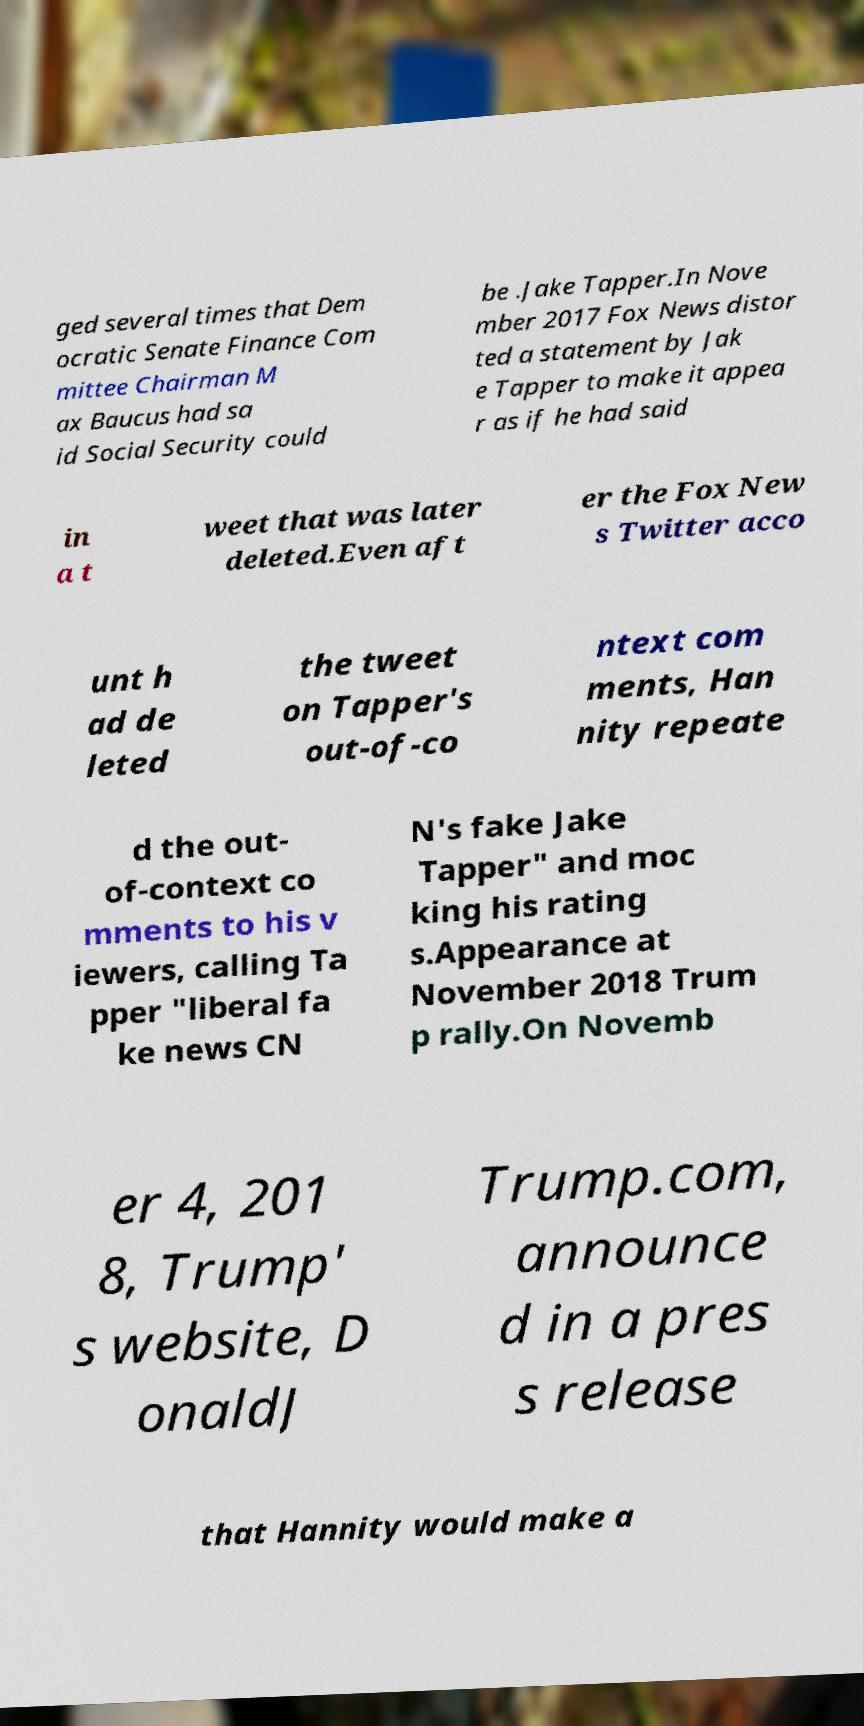There's text embedded in this image that I need extracted. Can you transcribe it verbatim? ged several times that Dem ocratic Senate Finance Com mittee Chairman M ax Baucus had sa id Social Security could be .Jake Tapper.In Nove mber 2017 Fox News distor ted a statement by Jak e Tapper to make it appea r as if he had said in a t weet that was later deleted.Even aft er the Fox New s Twitter acco unt h ad de leted the tweet on Tapper's out-of-co ntext com ments, Han nity repeate d the out- of-context co mments to his v iewers, calling Ta pper "liberal fa ke news CN N's fake Jake Tapper" and moc king his rating s.Appearance at November 2018 Trum p rally.On Novemb er 4, 201 8, Trump' s website, D onaldJ Trump.com, announce d in a pres s release that Hannity would make a 